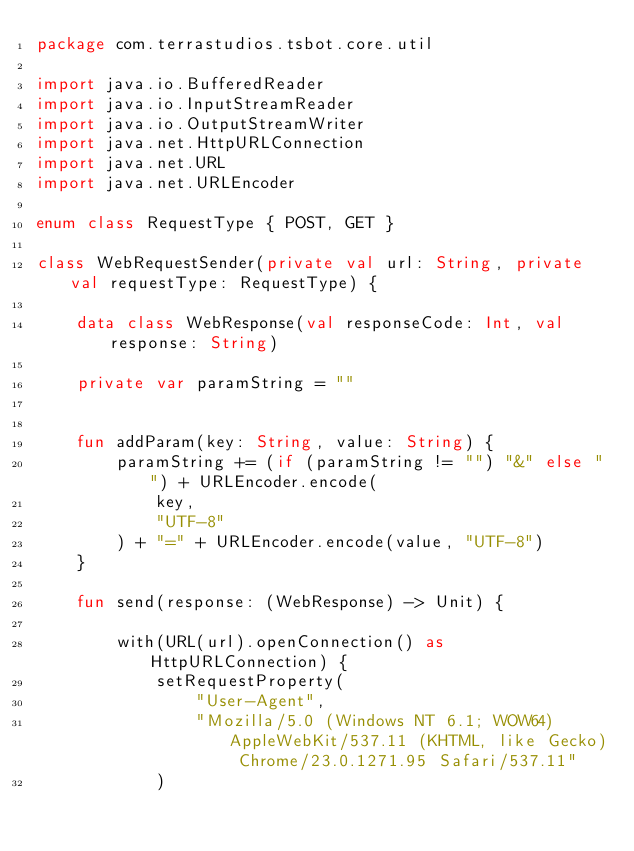Convert code to text. <code><loc_0><loc_0><loc_500><loc_500><_Kotlin_>package com.terrastudios.tsbot.core.util

import java.io.BufferedReader
import java.io.InputStreamReader
import java.io.OutputStreamWriter
import java.net.HttpURLConnection
import java.net.URL
import java.net.URLEncoder

enum class RequestType { POST, GET }

class WebRequestSender(private val url: String, private val requestType: RequestType) {

    data class WebResponse(val responseCode: Int, val response: String)

    private var paramString = ""


    fun addParam(key: String, value: String) {
        paramString += (if (paramString != "") "&" else "") + URLEncoder.encode(
            key,
            "UTF-8"
        ) + "=" + URLEncoder.encode(value, "UTF-8")
    }

    fun send(response: (WebResponse) -> Unit) {

        with(URL(url).openConnection() as HttpURLConnection) {
            setRequestProperty(
                "User-Agent",
                "Mozilla/5.0 (Windows NT 6.1; WOW64) AppleWebKit/537.11 (KHTML, like Gecko) Chrome/23.0.1271.95 Safari/537.11"
            )</code> 